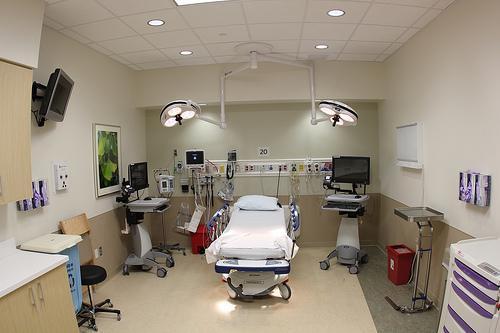How many red stools are there?
Give a very brief answer. 0. 